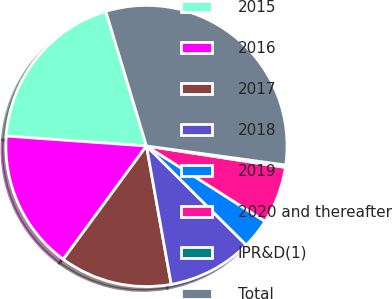Convert chart to OTSL. <chart><loc_0><loc_0><loc_500><loc_500><pie_chart><fcel>2015<fcel>2016<fcel>2017<fcel>2018<fcel>2019<fcel>2020 and thereafter<fcel>IPR&D(1)<fcel>Total<nl><fcel>19.21%<fcel>16.05%<fcel>12.89%<fcel>9.74%<fcel>3.43%<fcel>6.58%<fcel>0.27%<fcel>31.83%<nl></chart> 